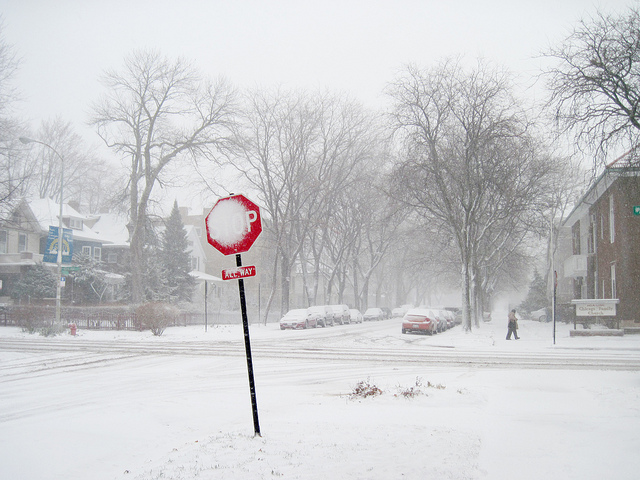Read and extract the text from this image. STOP 